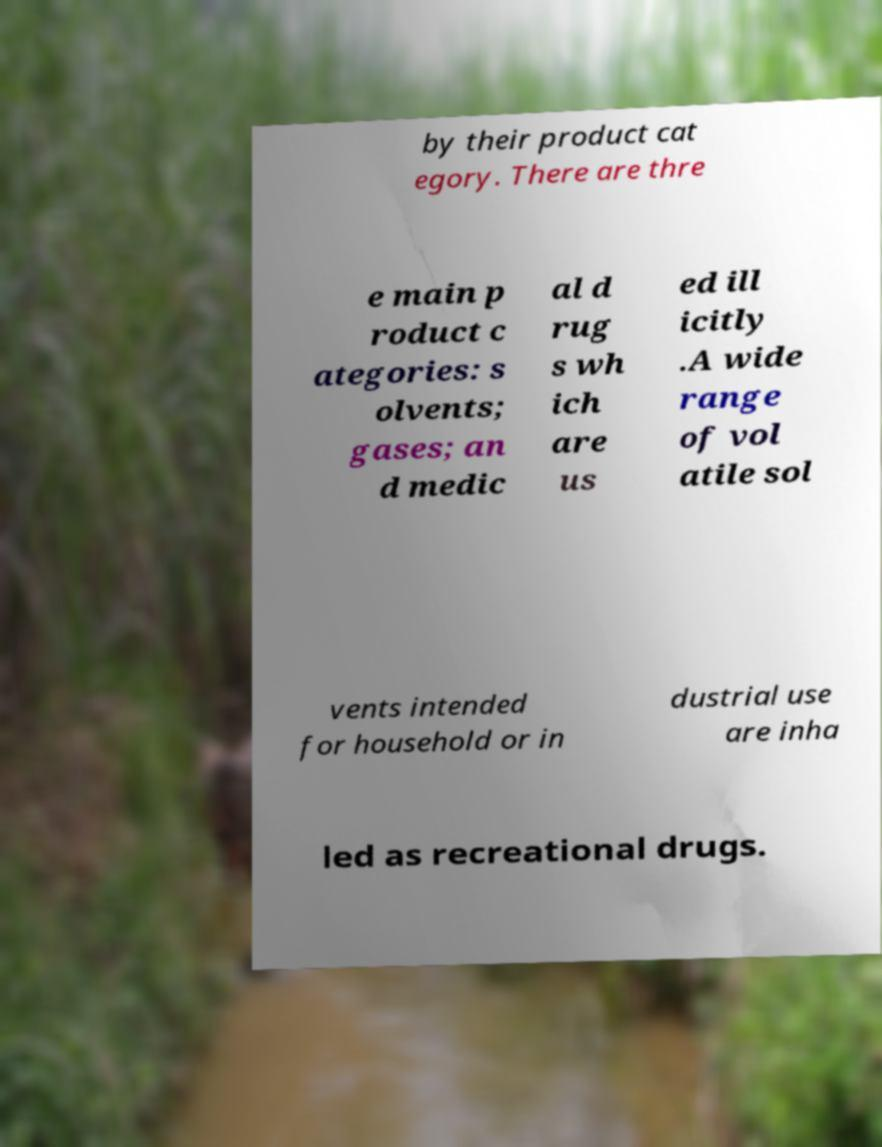Can you read and provide the text displayed in the image?This photo seems to have some interesting text. Can you extract and type it out for me? by their product cat egory. There are thre e main p roduct c ategories: s olvents; gases; an d medic al d rug s wh ich are us ed ill icitly .A wide range of vol atile sol vents intended for household or in dustrial use are inha led as recreational drugs. 